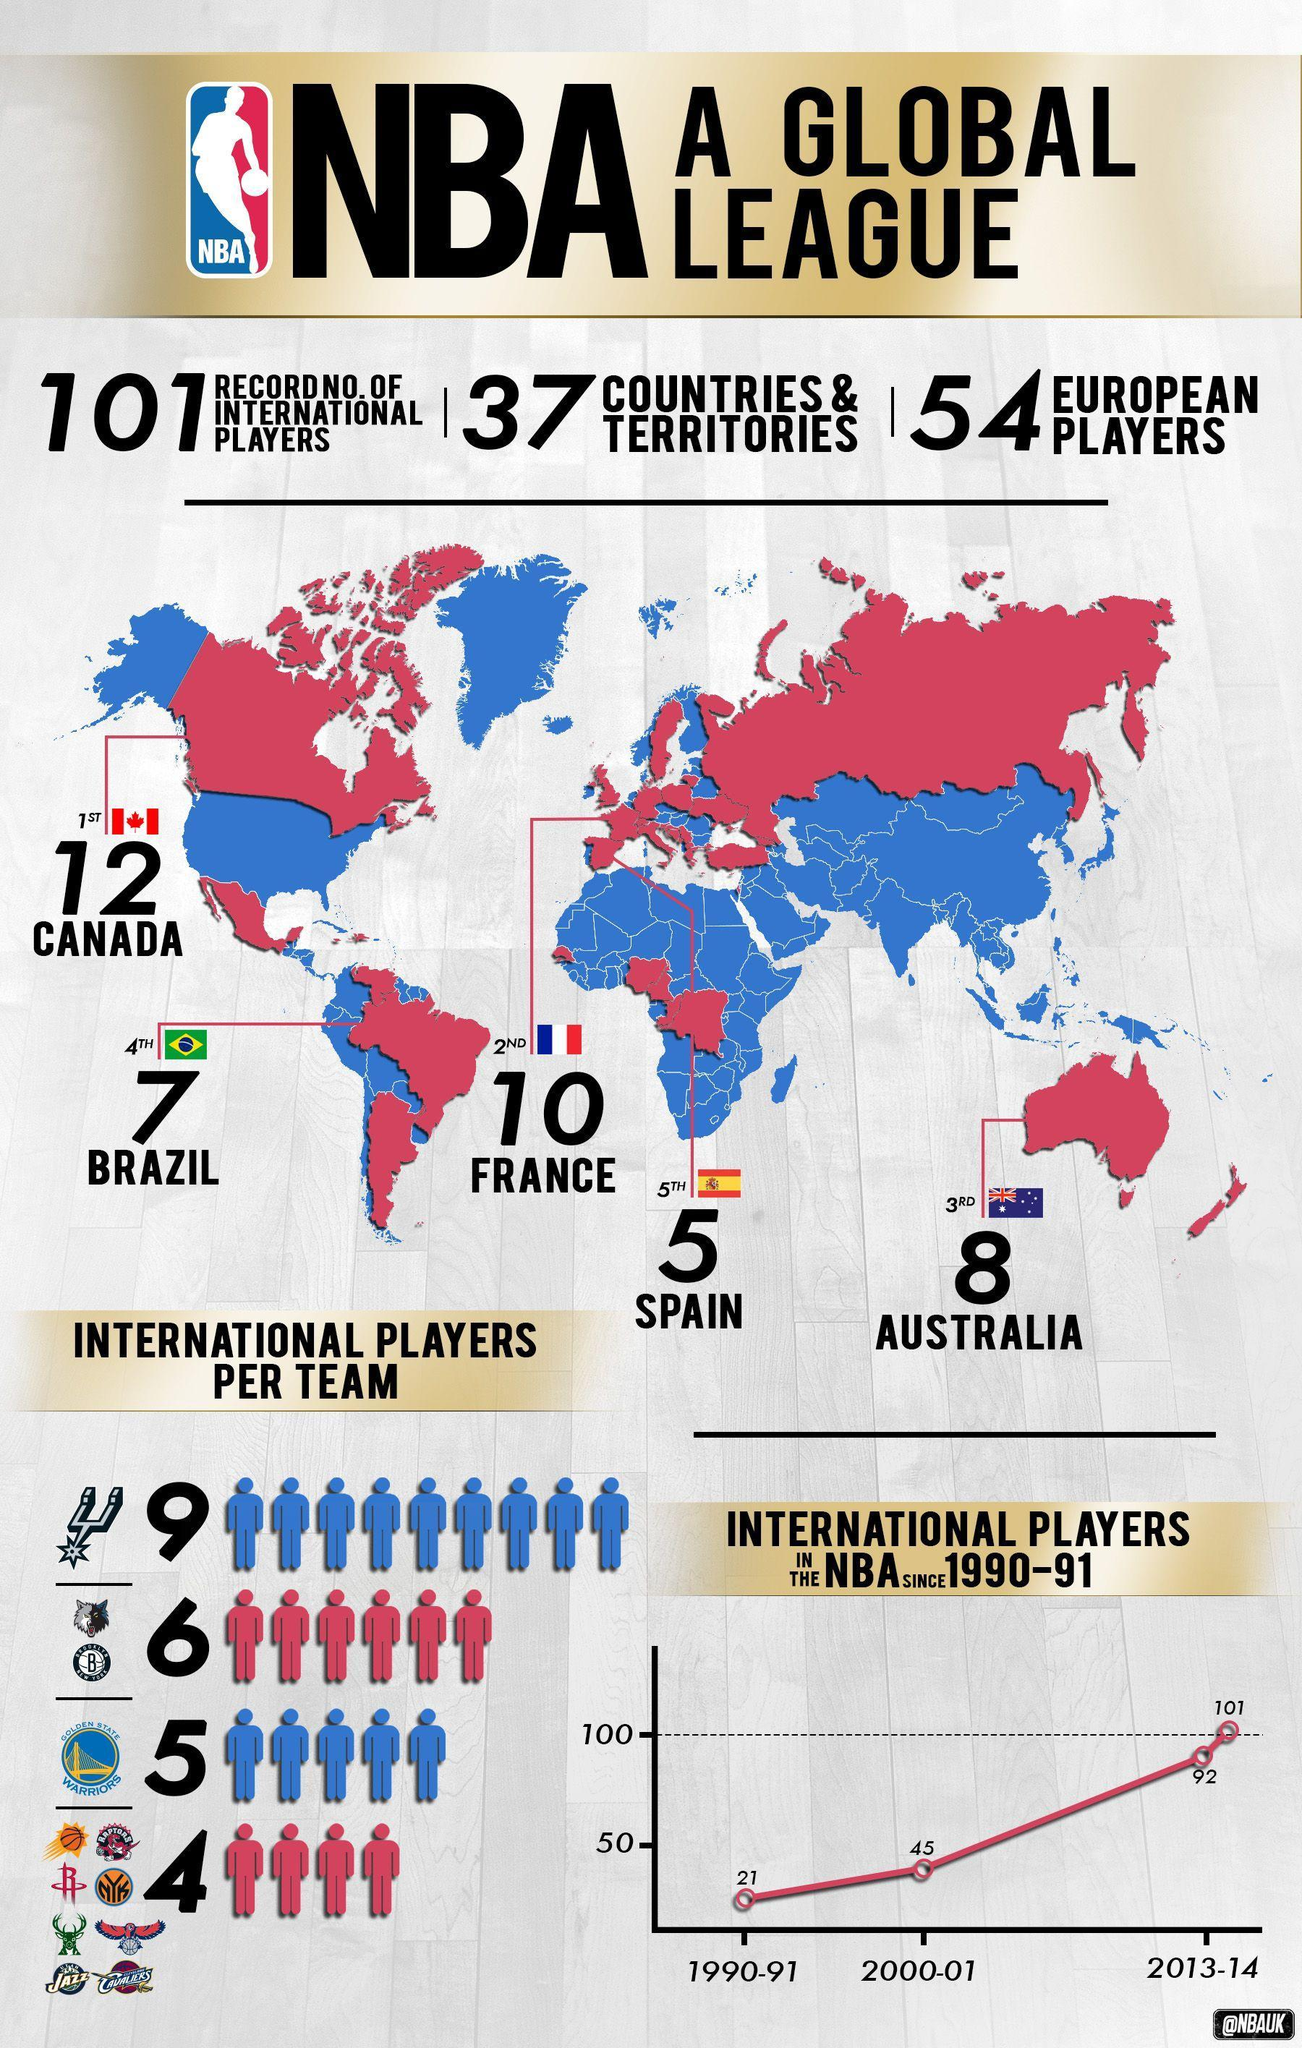What is the total number of international players in the NBA in 1990-91 and 2000-01?
Answer the question with a short phrase. 66 